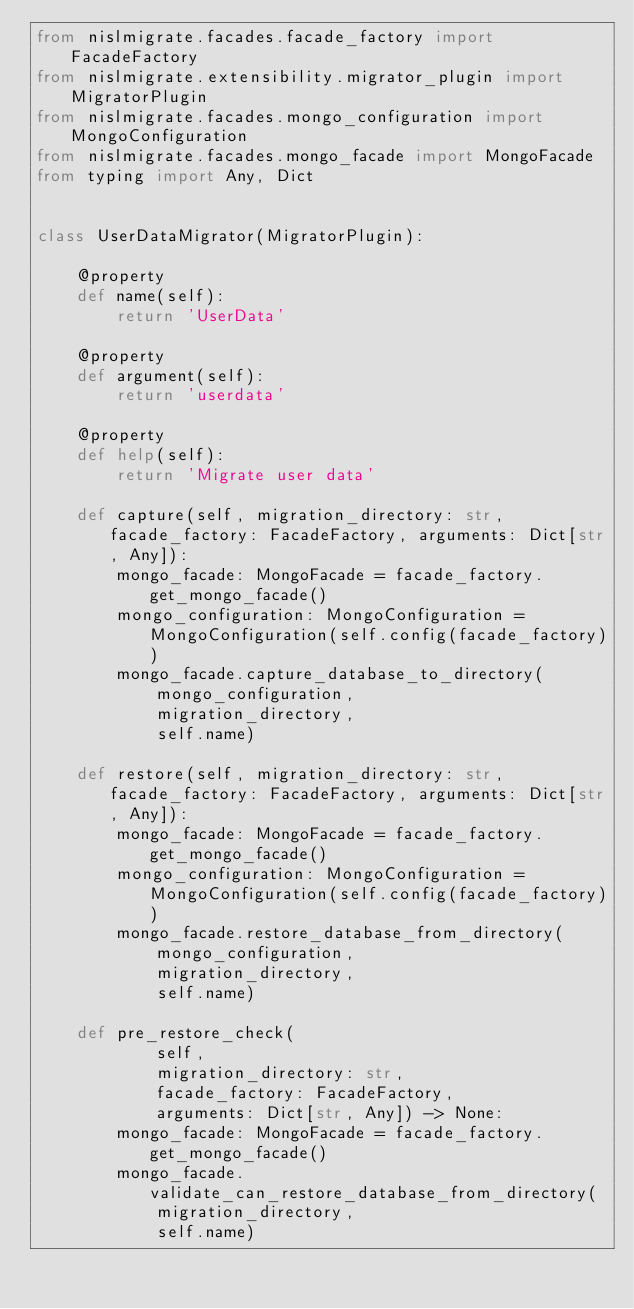Convert code to text. <code><loc_0><loc_0><loc_500><loc_500><_Python_>from nislmigrate.facades.facade_factory import FacadeFactory
from nislmigrate.extensibility.migrator_plugin import MigratorPlugin
from nislmigrate.facades.mongo_configuration import MongoConfiguration
from nislmigrate.facades.mongo_facade import MongoFacade
from typing import Any, Dict


class UserDataMigrator(MigratorPlugin):

    @property
    def name(self):
        return 'UserData'

    @property
    def argument(self):
        return 'userdata'

    @property
    def help(self):
        return 'Migrate user data'

    def capture(self, migration_directory: str, facade_factory: FacadeFactory, arguments: Dict[str, Any]):
        mongo_facade: MongoFacade = facade_factory.get_mongo_facade()
        mongo_configuration: MongoConfiguration = MongoConfiguration(self.config(facade_factory))
        mongo_facade.capture_database_to_directory(
            mongo_configuration,
            migration_directory,
            self.name)

    def restore(self, migration_directory: str, facade_factory: FacadeFactory, arguments: Dict[str, Any]):
        mongo_facade: MongoFacade = facade_factory.get_mongo_facade()
        mongo_configuration: MongoConfiguration = MongoConfiguration(self.config(facade_factory))
        mongo_facade.restore_database_from_directory(
            mongo_configuration,
            migration_directory,
            self.name)

    def pre_restore_check(
            self,
            migration_directory: str,
            facade_factory: FacadeFactory,
            arguments: Dict[str, Any]) -> None:
        mongo_facade: MongoFacade = facade_factory.get_mongo_facade()
        mongo_facade.validate_can_restore_database_from_directory(
            migration_directory,
            self.name)
</code> 